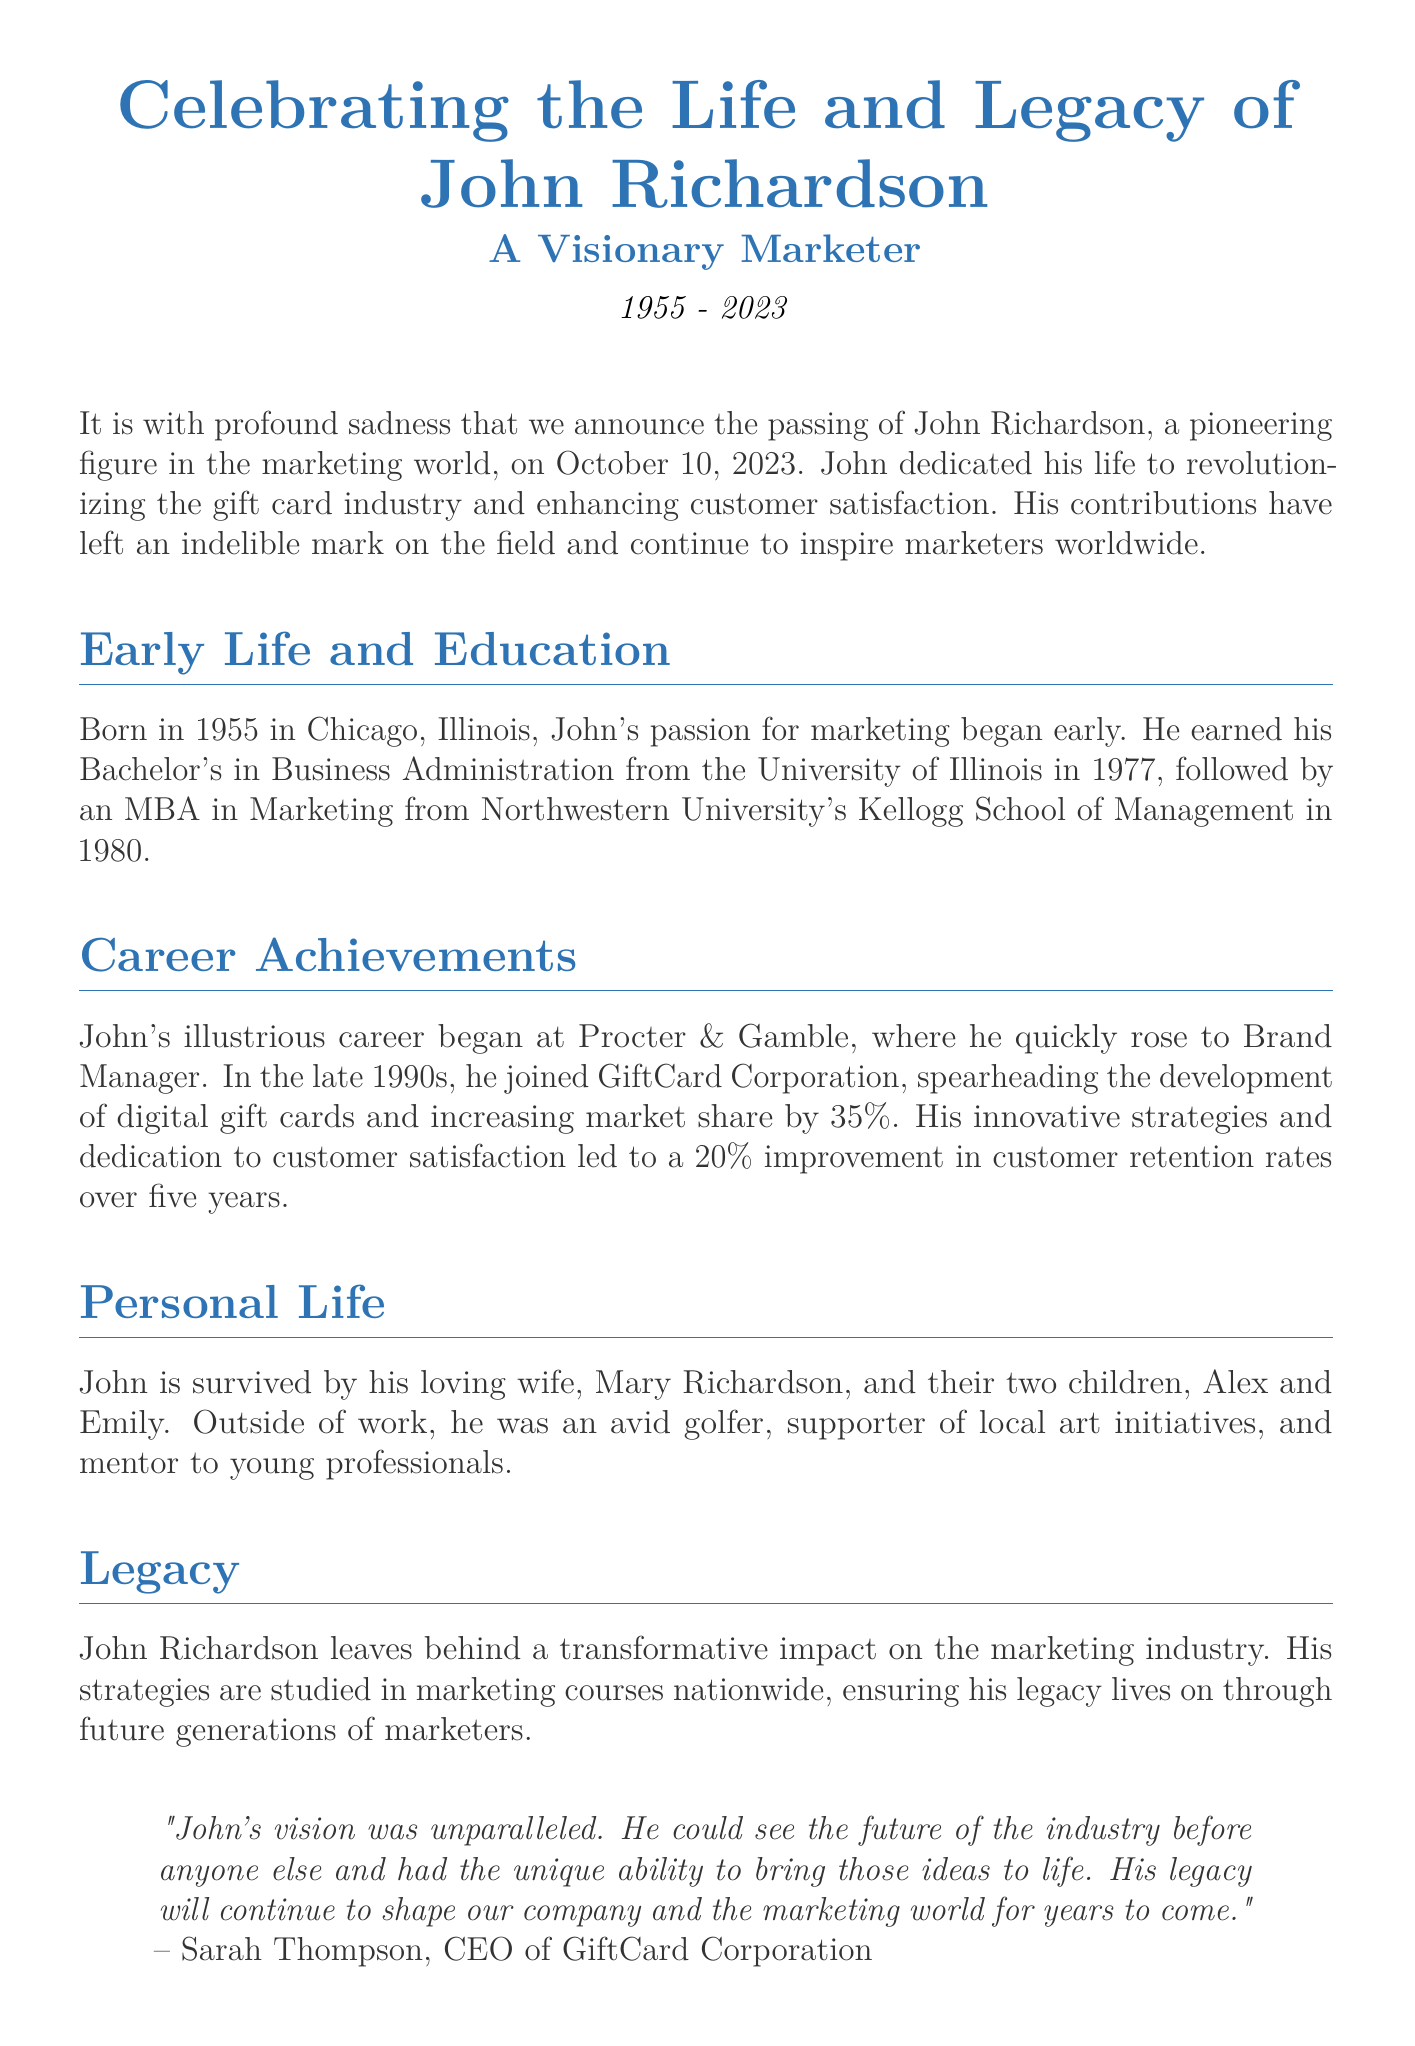What date did John Richardson pass away? The document states John Richardson passed away on October 10, 2023.
Answer: October 10, 2023 Who was the CEO of GiftCard Corporation? The obituary includes a quote from Sarah Thompson, identifying her as the CEO of GiftCard Corporation.
Answer: Sarah Thompson What degree did John earn in 1980? The document mentions he earned an MBA in Marketing from Northwestern University's Kellogg School of Management in 1980.
Answer: MBA in Marketing How much did John increase market share by at GiftCard Corporation? The document notes that he increased market share by 35%.
Answer: 35% What was John's early job title at Procter & Gamble? The obituary states he began as Brand Manager at Procter & Gamble.
Answer: Brand Manager What is the name of John Richardson's wife? His wife's name is mentioned as Mary Richardson in the document.
Answer: Mary Richardson What year was John born? The document states John was born in 1955.
Answer: 1955 What sport did John enjoy outside of work? The obituary mentions he was an avid golfer.
Answer: Golfer What impact did John leave on the marketing industry? The document describes his impact as transformative, specifically in the gift card industry.
Answer: Transformative impact 